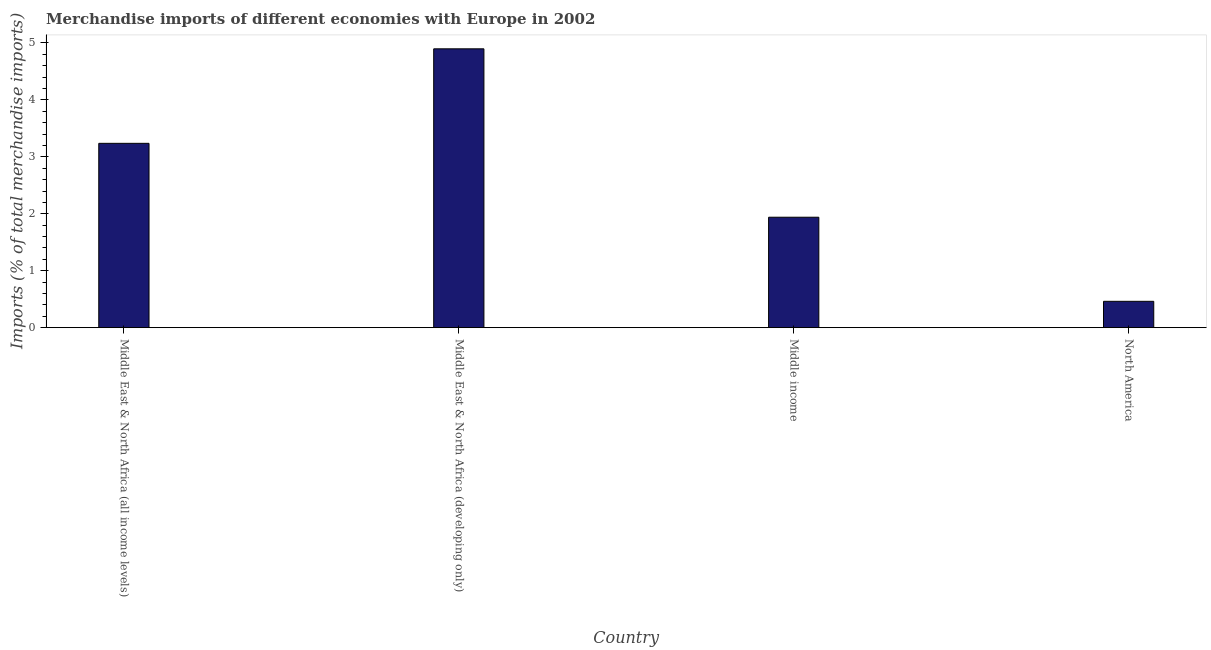Does the graph contain any zero values?
Your answer should be very brief. No. What is the title of the graph?
Offer a terse response. Merchandise imports of different economies with Europe in 2002. What is the label or title of the X-axis?
Your response must be concise. Country. What is the label or title of the Y-axis?
Your answer should be very brief. Imports (% of total merchandise imports). What is the merchandise imports in Middle East & North Africa (developing only)?
Your answer should be very brief. 4.9. Across all countries, what is the maximum merchandise imports?
Offer a terse response. 4.9. Across all countries, what is the minimum merchandise imports?
Your response must be concise. 0.46. In which country was the merchandise imports maximum?
Give a very brief answer. Middle East & North Africa (developing only). What is the sum of the merchandise imports?
Ensure brevity in your answer.  10.54. What is the difference between the merchandise imports in Middle East & North Africa (developing only) and North America?
Give a very brief answer. 4.43. What is the average merchandise imports per country?
Your answer should be very brief. 2.63. What is the median merchandise imports?
Keep it short and to the point. 2.59. In how many countries, is the merchandise imports greater than 2.8 %?
Ensure brevity in your answer.  2. What is the ratio of the merchandise imports in Middle East & North Africa (all income levels) to that in Middle East & North Africa (developing only)?
Offer a very short reply. 0.66. Is the difference between the merchandise imports in Middle East & North Africa (all income levels) and Middle income greater than the difference between any two countries?
Offer a terse response. No. What is the difference between the highest and the second highest merchandise imports?
Your response must be concise. 1.66. Is the sum of the merchandise imports in Middle East & North Africa (all income levels) and North America greater than the maximum merchandise imports across all countries?
Keep it short and to the point. No. What is the difference between the highest and the lowest merchandise imports?
Offer a very short reply. 4.43. Are all the bars in the graph horizontal?
Make the answer very short. No. What is the Imports (% of total merchandise imports) of Middle East & North Africa (all income levels)?
Your answer should be compact. 3.24. What is the Imports (% of total merchandise imports) of Middle East & North Africa (developing only)?
Provide a short and direct response. 4.9. What is the Imports (% of total merchandise imports) of Middle income?
Keep it short and to the point. 1.94. What is the Imports (% of total merchandise imports) in North America?
Give a very brief answer. 0.46. What is the difference between the Imports (% of total merchandise imports) in Middle East & North Africa (all income levels) and Middle East & North Africa (developing only)?
Offer a very short reply. -1.66. What is the difference between the Imports (% of total merchandise imports) in Middle East & North Africa (all income levels) and Middle income?
Provide a short and direct response. 1.3. What is the difference between the Imports (% of total merchandise imports) in Middle East & North Africa (all income levels) and North America?
Offer a terse response. 2.77. What is the difference between the Imports (% of total merchandise imports) in Middle East & North Africa (developing only) and Middle income?
Give a very brief answer. 2.96. What is the difference between the Imports (% of total merchandise imports) in Middle East & North Africa (developing only) and North America?
Offer a terse response. 4.43. What is the difference between the Imports (% of total merchandise imports) in Middle income and North America?
Make the answer very short. 1.48. What is the ratio of the Imports (% of total merchandise imports) in Middle East & North Africa (all income levels) to that in Middle East & North Africa (developing only)?
Your answer should be very brief. 0.66. What is the ratio of the Imports (% of total merchandise imports) in Middle East & North Africa (all income levels) to that in Middle income?
Provide a succinct answer. 1.67. What is the ratio of the Imports (% of total merchandise imports) in Middle East & North Africa (all income levels) to that in North America?
Make the answer very short. 7. What is the ratio of the Imports (% of total merchandise imports) in Middle East & North Africa (developing only) to that in Middle income?
Offer a very short reply. 2.52. What is the ratio of the Imports (% of total merchandise imports) in Middle East & North Africa (developing only) to that in North America?
Give a very brief answer. 10.59. What is the ratio of the Imports (% of total merchandise imports) in Middle income to that in North America?
Your answer should be compact. 4.19. 